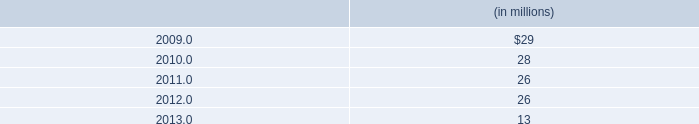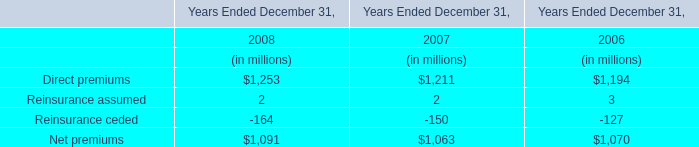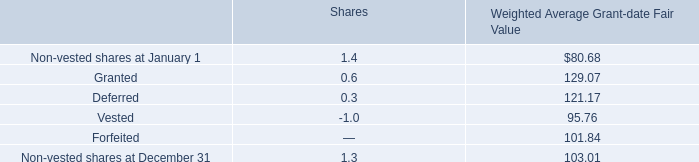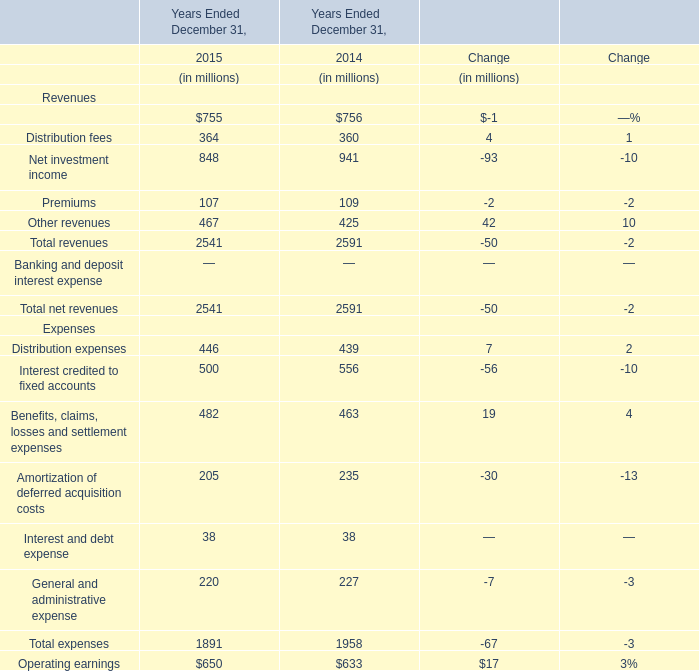What's the sum of Management and financial advice fees in the range of 1 and 1000 in 2014 and 2015? (in million) 
Computations: (755 + 756)
Answer: 1511.0. 